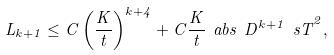Convert formula to latex. <formula><loc_0><loc_0><loc_500><loc_500>L _ { k + 1 } \leq C \left ( \frac { K } { t } \right ) ^ { k + 4 } + C \frac { K } { t } \ a b s { \ D ^ { k + 1 } \ s T } ^ { 2 } ,</formula> 